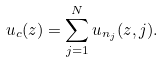<formula> <loc_0><loc_0><loc_500><loc_500>u _ { c } ( z ) = \sum _ { j = 1 } ^ { N } u _ { n _ { j } } ( z , j ) .</formula> 